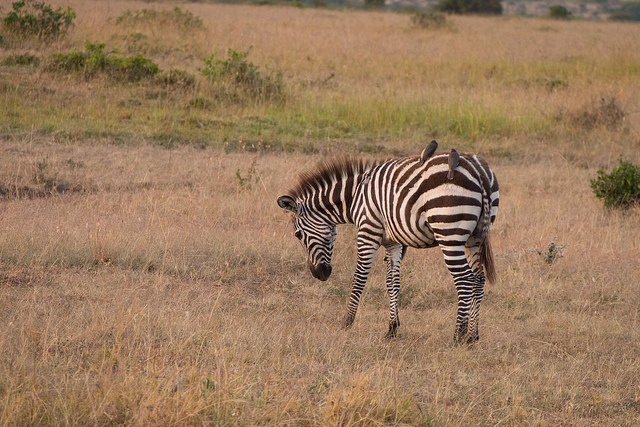Describe the objects in this image and their specific colors. I can see zebra in gray, black, and maroon tones, bird in gray, black, and maroon tones, bird in gray and black tones, and bird in gray, darkgreen, and darkgray tones in this image. 